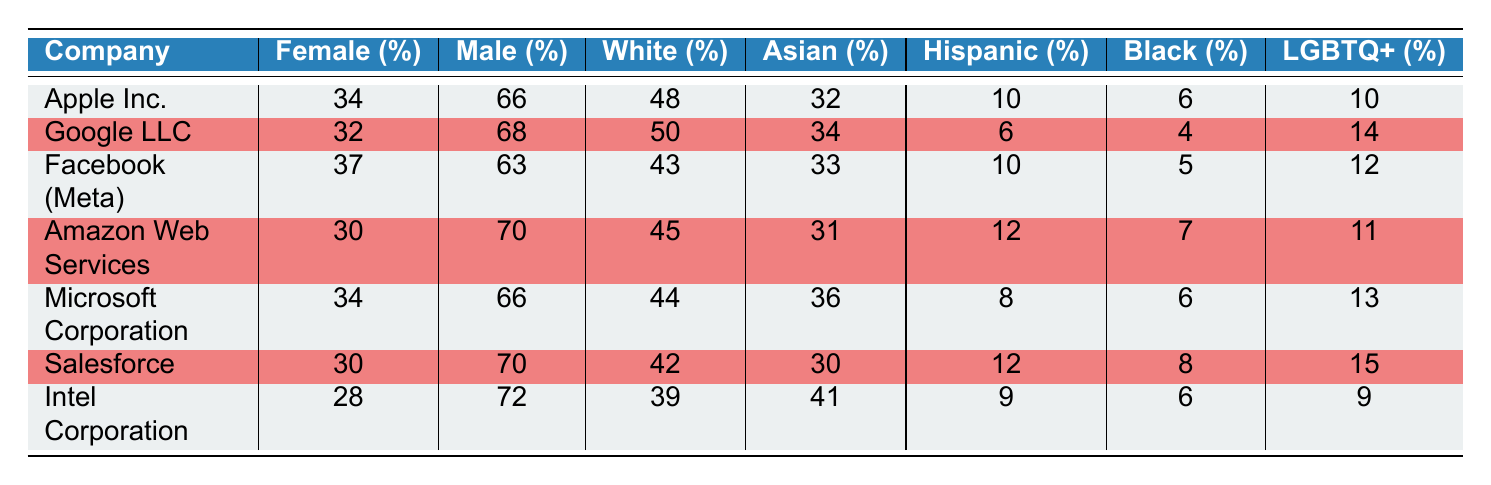What percentage of female employees does Google LLC have? According to the table, Google LLC has a female representation of 32%.
Answer: 32 Which company has the highest percentage of Black employees? By comparing the Black representation across the companies, Apple Inc. has 6%, which is higher than Google's 4%, Facebook's 5%, Amazon's 7%, Microsoft's 6%, Salesforce's 8%, and Intel's 6%. Therefore, the company with the highest percentage of Black employees is Salesforce with 8%.
Answer: 8 What is the average percentage of female representation among the companies listed? To find the average, sum the female percentages: (34 + 32 + 37 + 30 + 34 + 30 + 28) = 225. There are 7 companies, so the average is 225 / 7 ≈ 32.14.
Answer: 32.14 Did Intel Corporation have a higher percentage of male employees than Facebook? Intel Corporation has 72% male representation, while Facebook has 63% male representation. Therefore, Intel Corporation does have a higher percentage of male employees compared to Facebook.
Answer: Yes What is the difference in the percentage of Asian employees between Apple Inc. and Microsoft Corporation? Apple Inc. has 32% Asian representation, while Microsoft Corporation has 36%. To find the difference, subtract Apple's percentage from Microsoft's: 36 - 32 = 4.
Answer: 4 